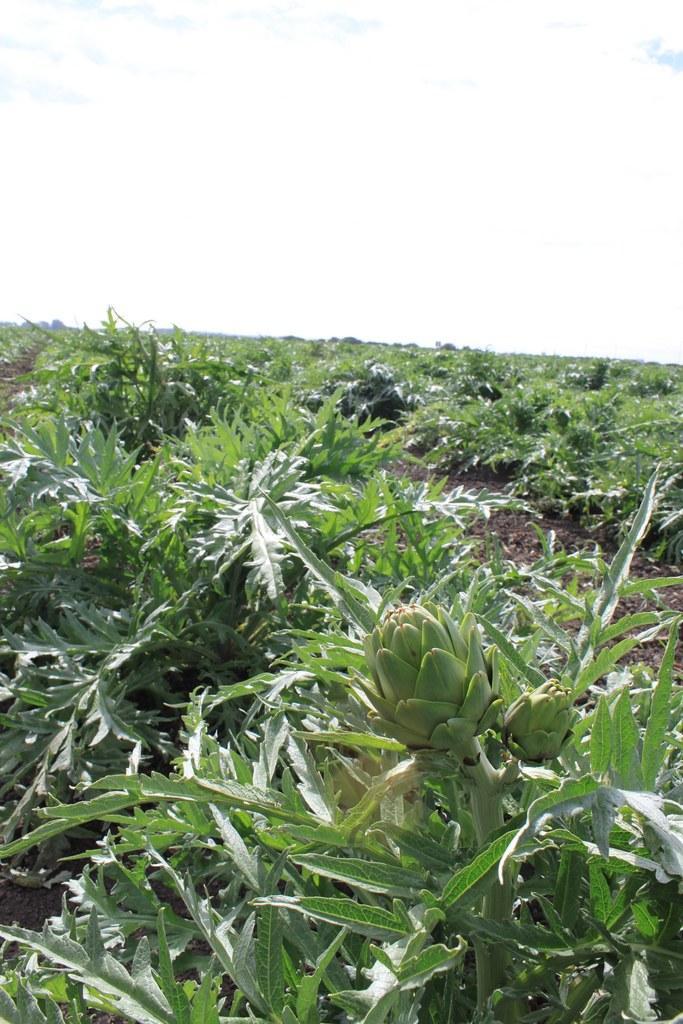How would you summarize this image in a sentence or two? In this picture we can see few plants. 